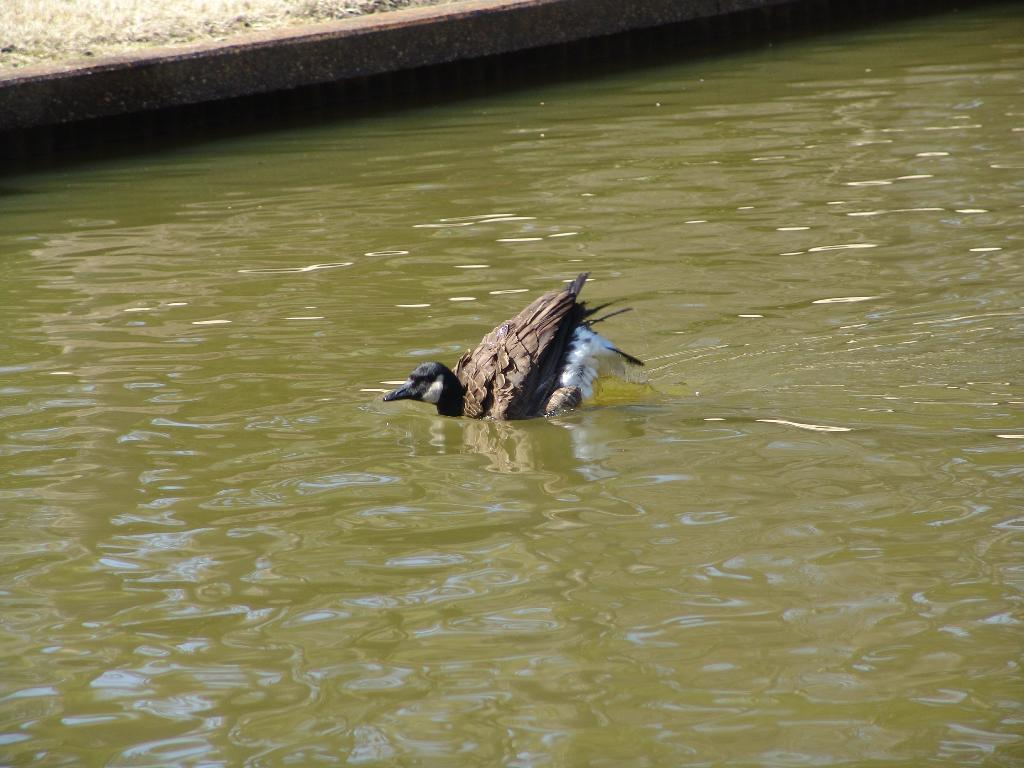What is on the water in the image? There is a bird on the water in the image. What type of vegetation can be seen at the top of the image? There is grass visible at the top of the image. How does the bird increase its speed while flying in the image? The bird is not flying in the image; it is on the water. Additionally, there is no information about the bird's speed or any increase in speed. 